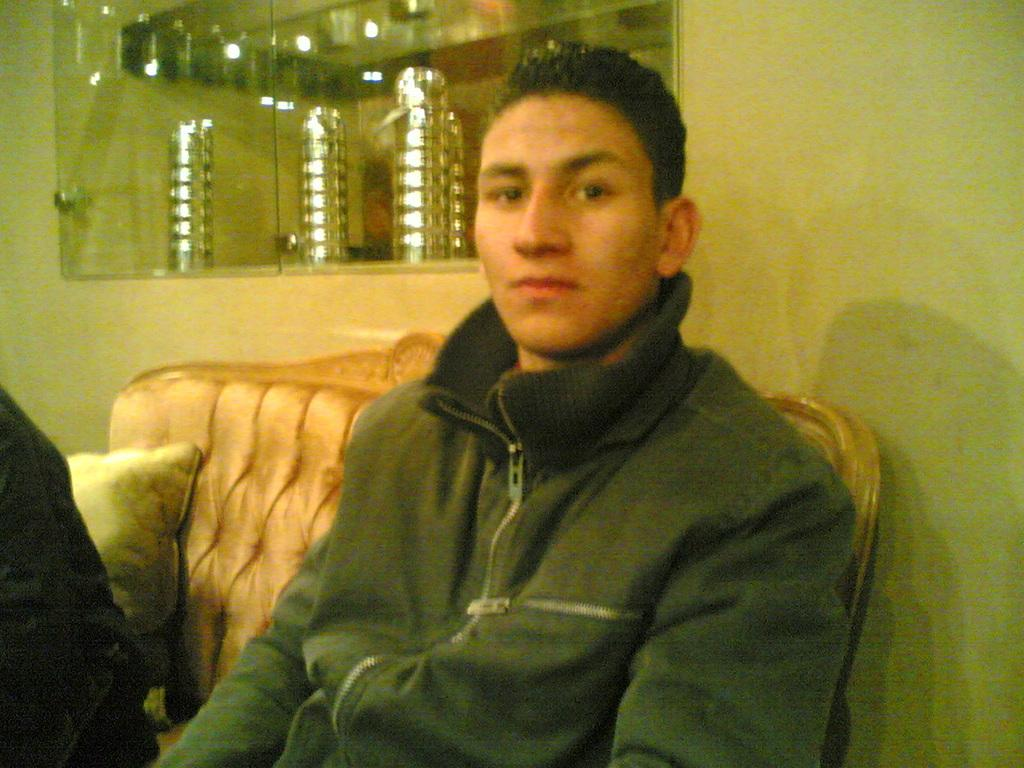Who is the main subject in the image? There is a boy in the center of the image. What is the boy doing in the image? The boy is sitting on a sofa. What can be seen at the top side of the image? There is a showcase at the top side of the image. Who else is present in the image? There is another man on the left side of the image. What type of plate is hanging on the hook in the image? There is no plate or hook present in the image. What kind of apparel is the boy wearing in the image? The provided facts do not mention the boy's clothing, so we cannot determine the type of apparel he is wearing. 